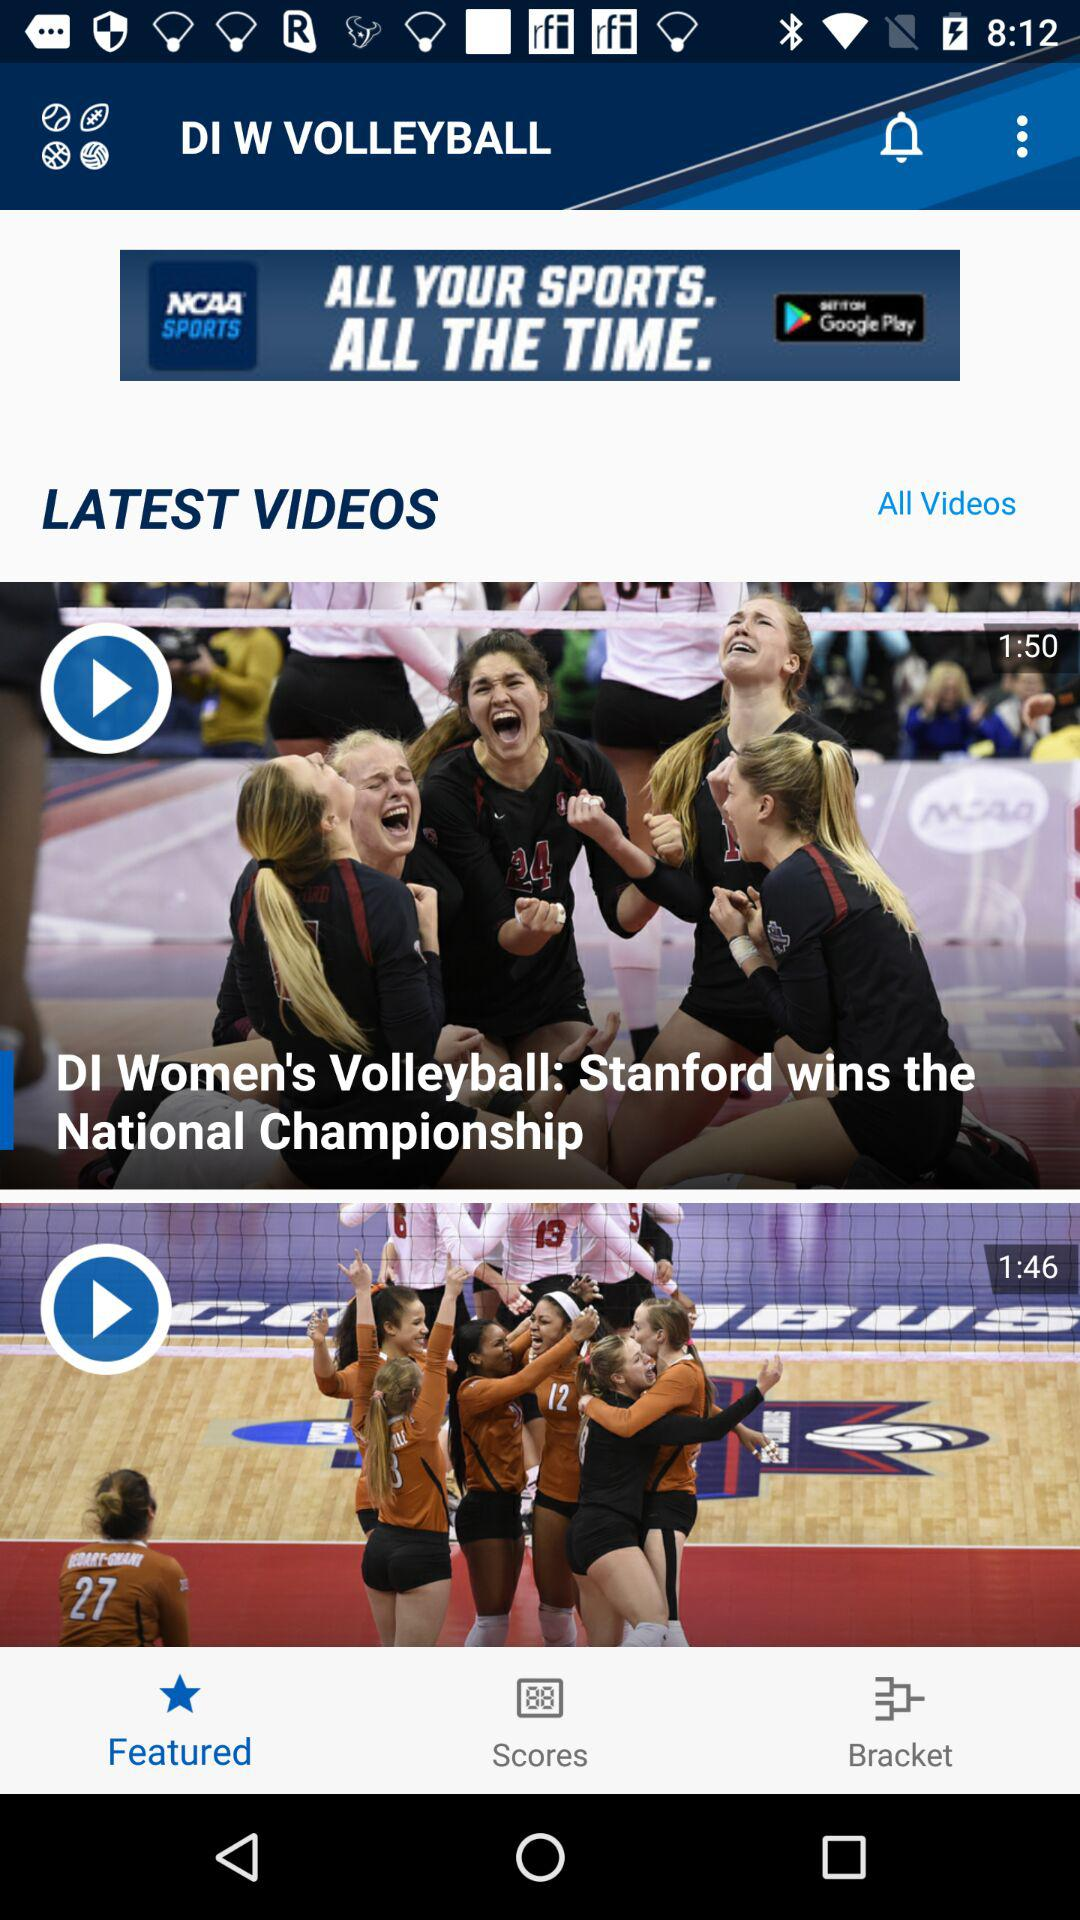How many more videos are there than advertisements?
Answer the question using a single word or phrase. 1 